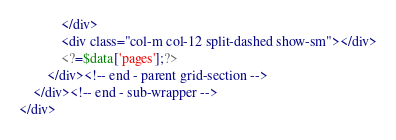Convert code to text. <code><loc_0><loc_0><loc_500><loc_500><_PHP_>            </div>
            <div class="col-m col-12 split-dashed show-sm"></div>
            <?=$data['pages'];?>
        </div><!-- end - parent grid-section -->
    </div><!-- end - sub-wrapper -->
</div></code> 